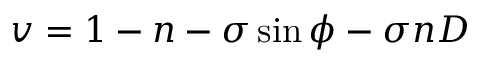Convert formula to latex. <formula><loc_0><loc_0><loc_500><loc_500>v = 1 - n - \sigma \sin { \phi } - \sigma n D</formula> 